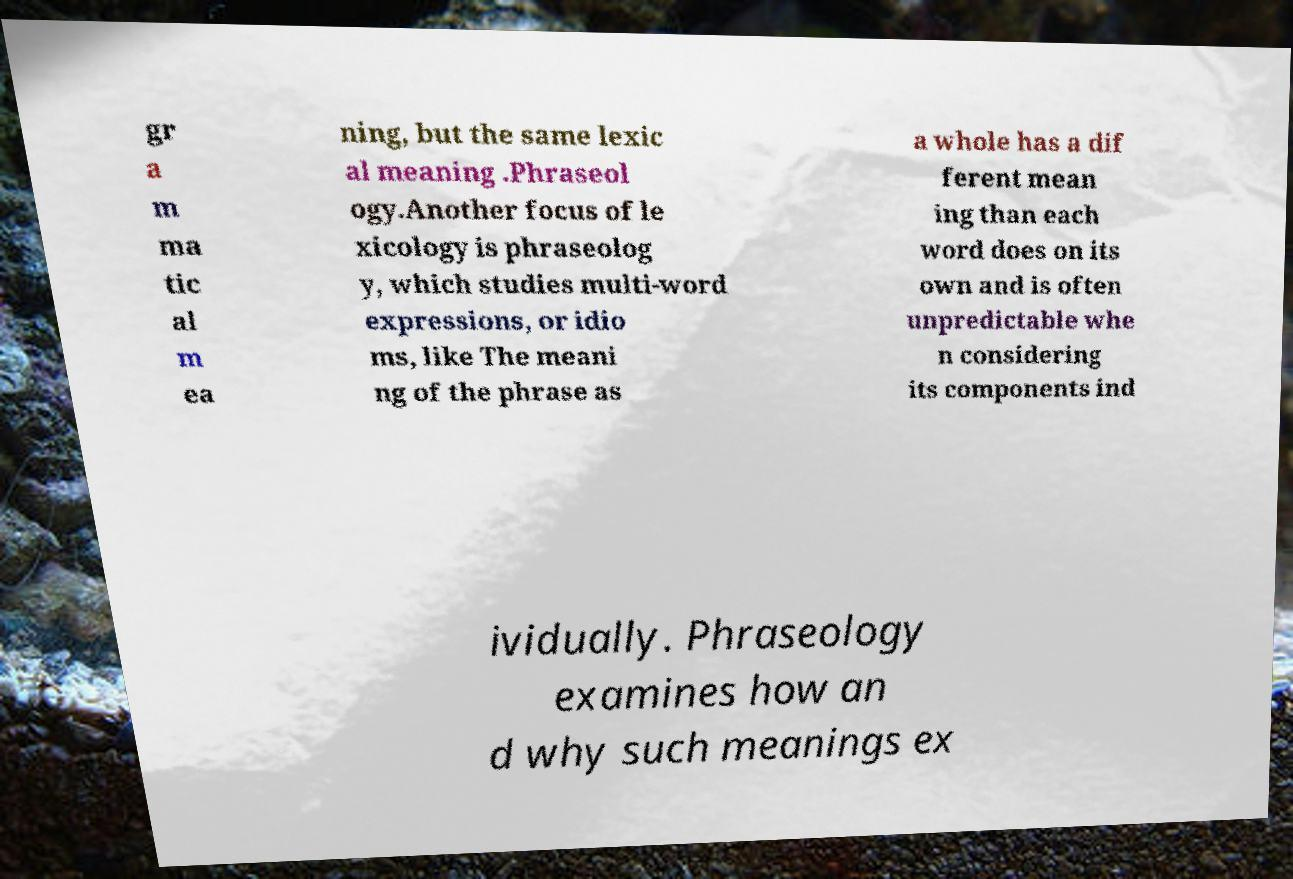Please identify and transcribe the text found in this image. gr a m ma tic al m ea ning, but the same lexic al meaning .Phraseol ogy.Another focus of le xicology is phraseolog y, which studies multi-word expressions, or idio ms, like The meani ng of the phrase as a whole has a dif ferent mean ing than each word does on its own and is often unpredictable whe n considering its components ind ividually. Phraseology examines how an d why such meanings ex 